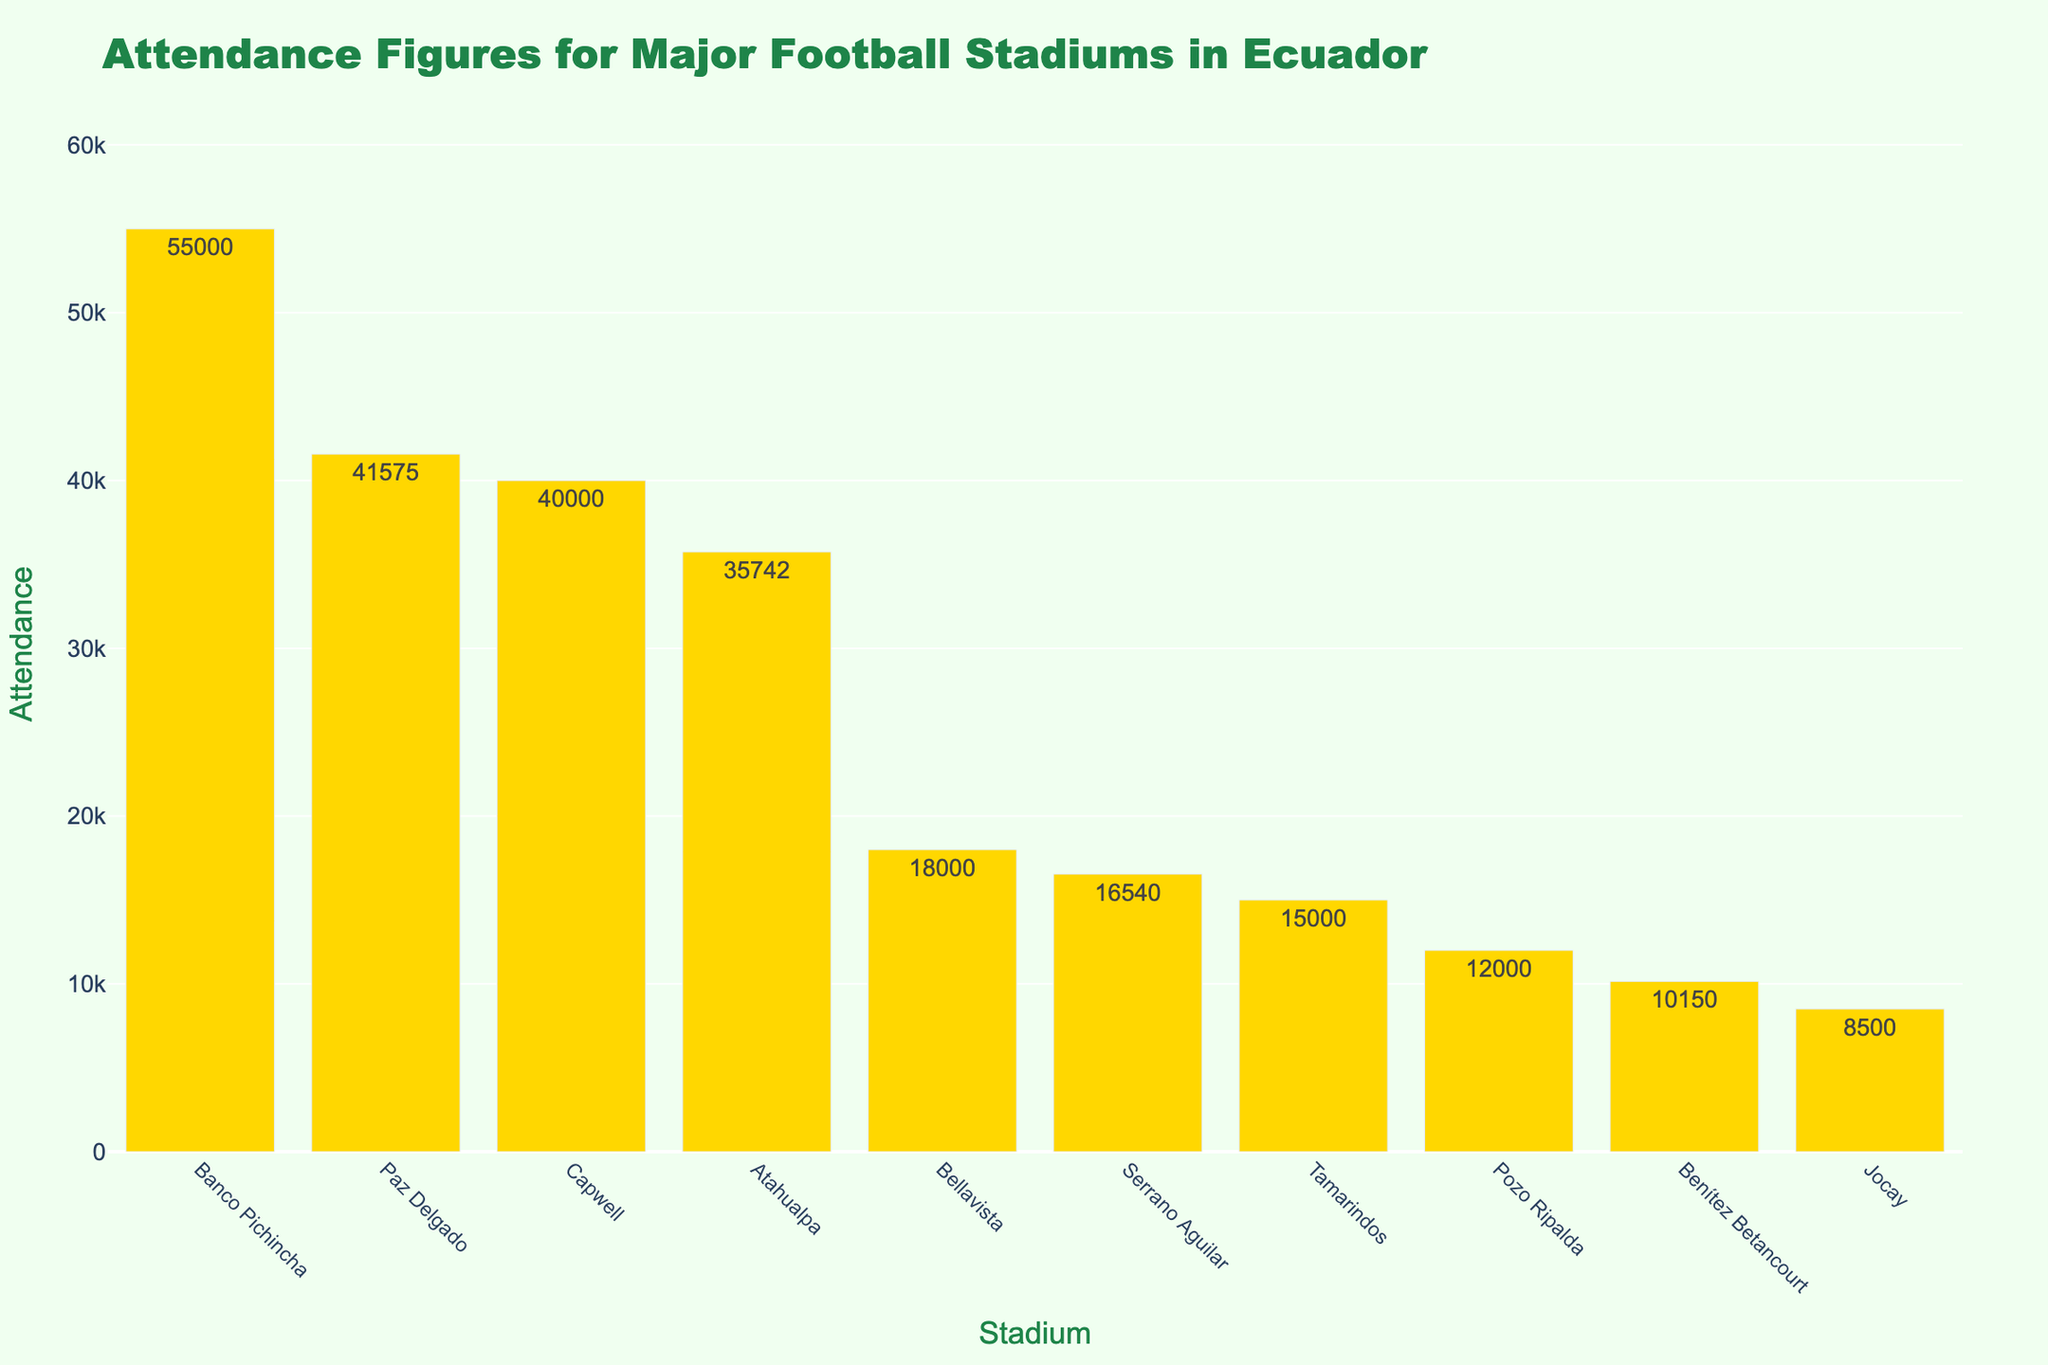What is the stadium with the highest attendance? The bar chart shows the attendance values in descending order. The tallest bar represents the stadium with the highest attendance.
Answer: Estadio Monumental Banco Pichincha Which stadium has the lowest attendance? The shortest bar in the chart represents the stadium with the lowest attendance.
Answer: Estadio Jocay How many stadiums have an attendance of more than 40,000? Count the number of stadiums whose bars have attendance values greater than 40,000. There are two such bars.
Answer: 2 What is the difference in attendance between Estadio Monumental Banco Pichincha and Estadio Rodrigo Paz Delgado? Find the height of the bars representing Estadio Monumental Banco Pichincha (55,000) and Estadio Rodrigo Paz Delgado (41,575), then subtract the latter from the former. 55000 - 41575 = 13425
Answer: 13,425 What is the total attendance for the three stadiums with the highest attendance figures? Sum the attendance for the top three stadiums: Estadio Monumental Banco Pichincha (55,000), Estadio Rodrigo Paz Delgado (41,575), and Estadio George Capwell (40,000). 55000 + 41575 + 40000 = 136575
Answer: 136,575 Which has a higher attendance, Estadio George Capwell or Estadio Olímpico Atahualpa? Compare the heights of the bars for both stadiums. Estadio George Capwell has an attendance of 40,000, and Estadio Olímpico Atahualpa has 35,742.
Answer: Estadio George Capwell What is the average attendance of the top five stadiums? Sum the attendance for the top five stadiums and divide by five: (55,000 + 41,575 + 40,000 + 35,742 + 18,000) / 5. The calculation is 190317 / 5 = 38063.4
Answer: 38,063.4 What is the median attendance value of all the stadiums? List the attendance figures in ascending order and find the middle value. The sorted attendances are: 8,500, 10,150, 12,000, 15,000, 16,540, 18,000, 35,742, 40,000, 41,575, 55,000. The median is the average of the 5th and 6th values: (16,540 + 18,000) / 2 = 17,270
Answer: 17,270 How many stadiums have an attendance less than the average attendance of all the stadiums? Calculate the average attendance: (55,000 + 41,575 + 40,000 + 35,742 + 18,000 + 16,540 + 15,000 + 12,000 + 10,150 + 8,500) / 10. The calculation is 252507 / 10 = 25250.7. Count the number of stadiums with attendance less than this value. There are five such stadiums.
Answer: 5 